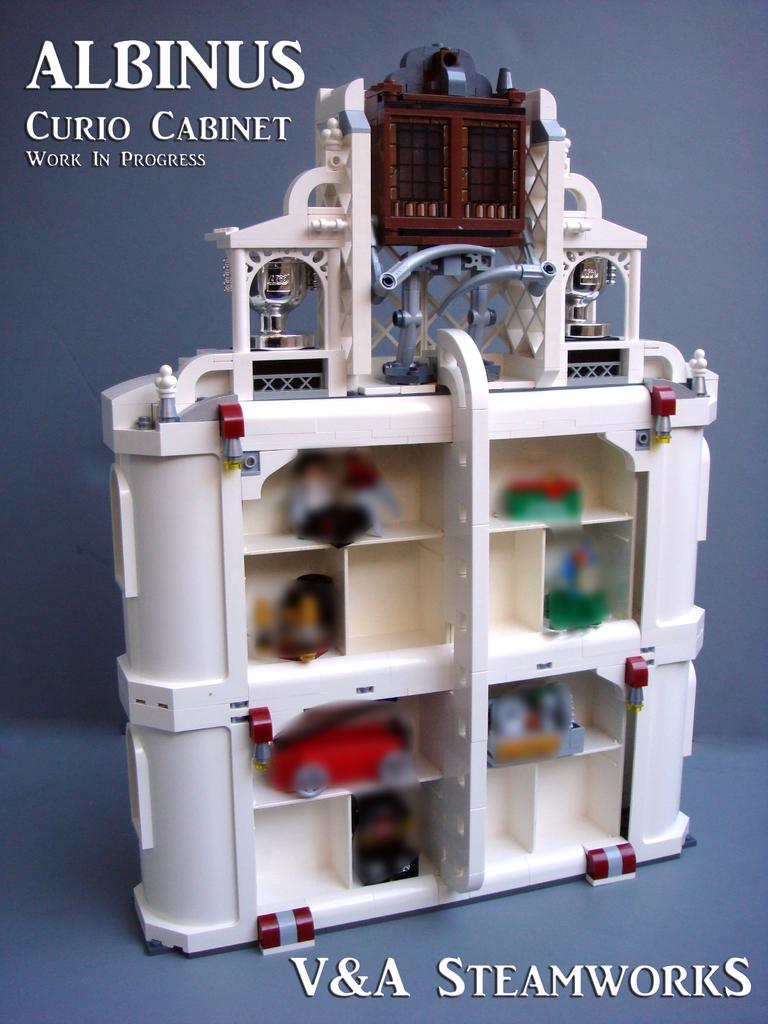<image>
Offer a succinct explanation of the picture presented. a V&A steamworks ad with a toy on it 